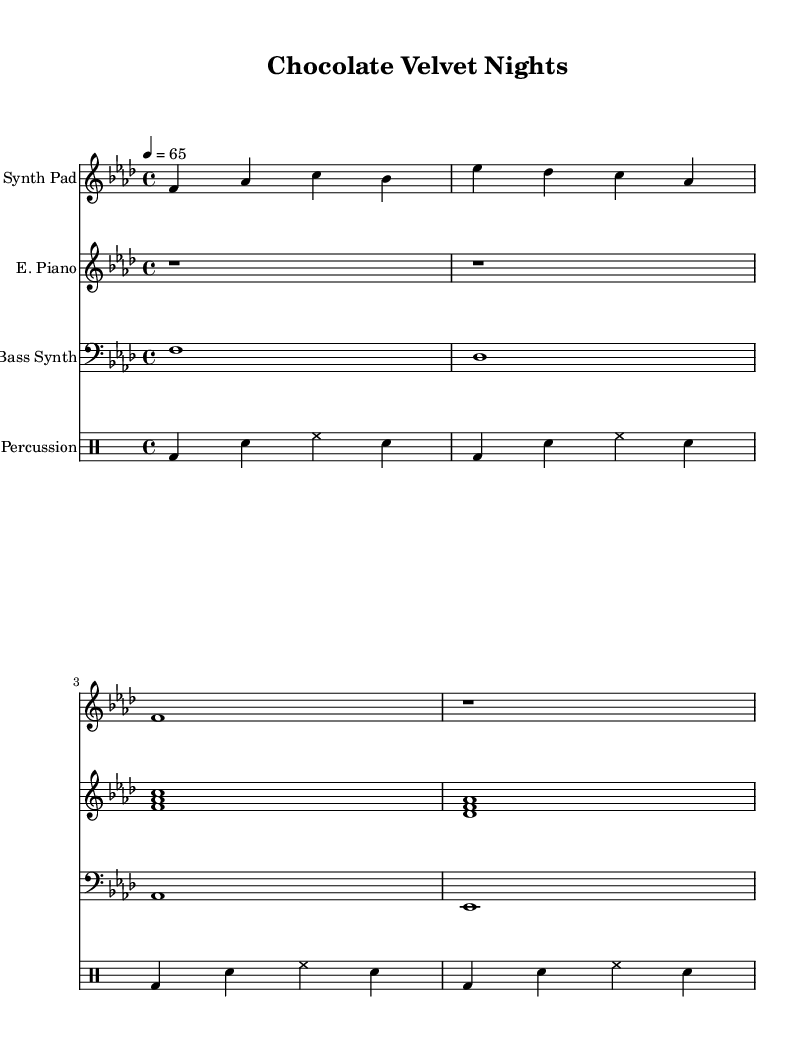What is the key signature of this music? The key signature is indicated at the beginning of the staff and shows one flat (B flat) in the key signature, which corresponds to F minor.
Answer: F minor What is the time signature of the piece? The time signature is found after the key signature, showing four beats per measure, thus it is 4/4 time.
Answer: 4/4 What is the tempo marking for this composition? The tempo marking is indicated at the beginning of the score, showing that the piece should be played at 65 beats per minute.
Answer: 65 How many measures does the Synth Pad part contain? By counting the measures in the Synth Pad staff, there are a total of four measures visible in this excerpt of the score.
Answer: 4 What instruments are used in this piece? The instruments are listed at the beginning of each staff. Here we have Synth Pad, Electric Piano, Bass Synth, and Percussion.
Answer: Synth Pad, Electric Piano, Bass Synth, Percussion What type of music does this piece represent? The title and instruments suggest that this piece belongs to the ambient electronic genre, known for its chill and atmospheric soundscapes ideal for cocktail receptions.
Answer: Ambient electronic 